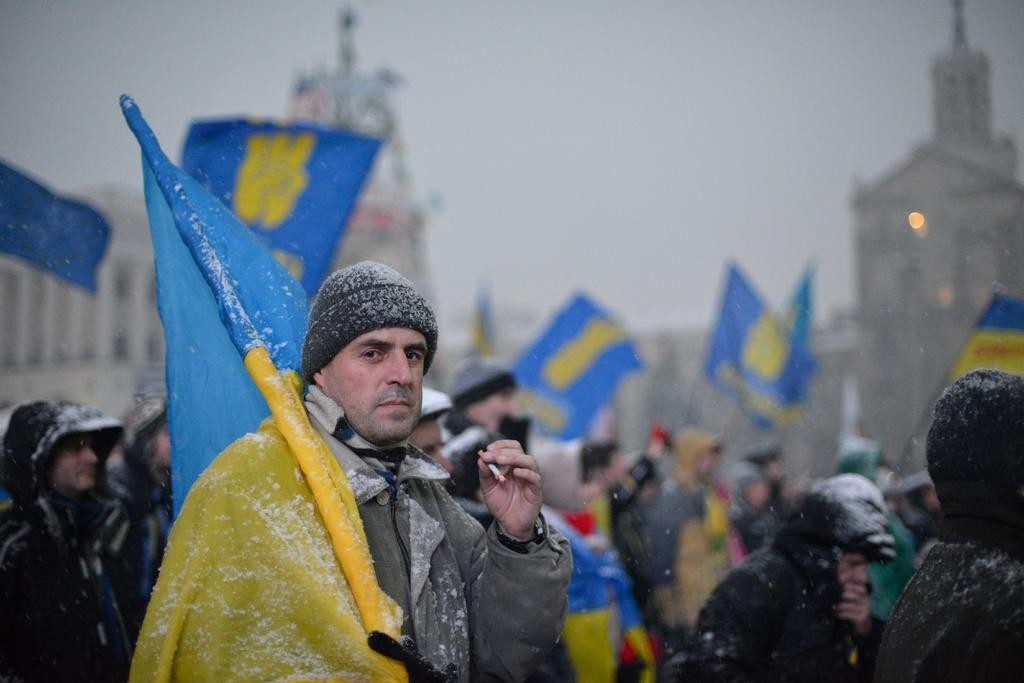How many people are in the image? There is a group of people in the image. What is a person in the foreground holding? A person in the foreground is holding a flag and another person is holding a cigarette. What can be seen in the background of the image? There are buildings visible in the background of the image. What type of pest can be seen crawling on the flag in the image? There is no pest visible on the flag in the image. Can you describe the jellyfish swimming in the background of the image? There are no jellyfish present in the image; it features a group of people, a flag, a cigarette, and buildings in the background. 